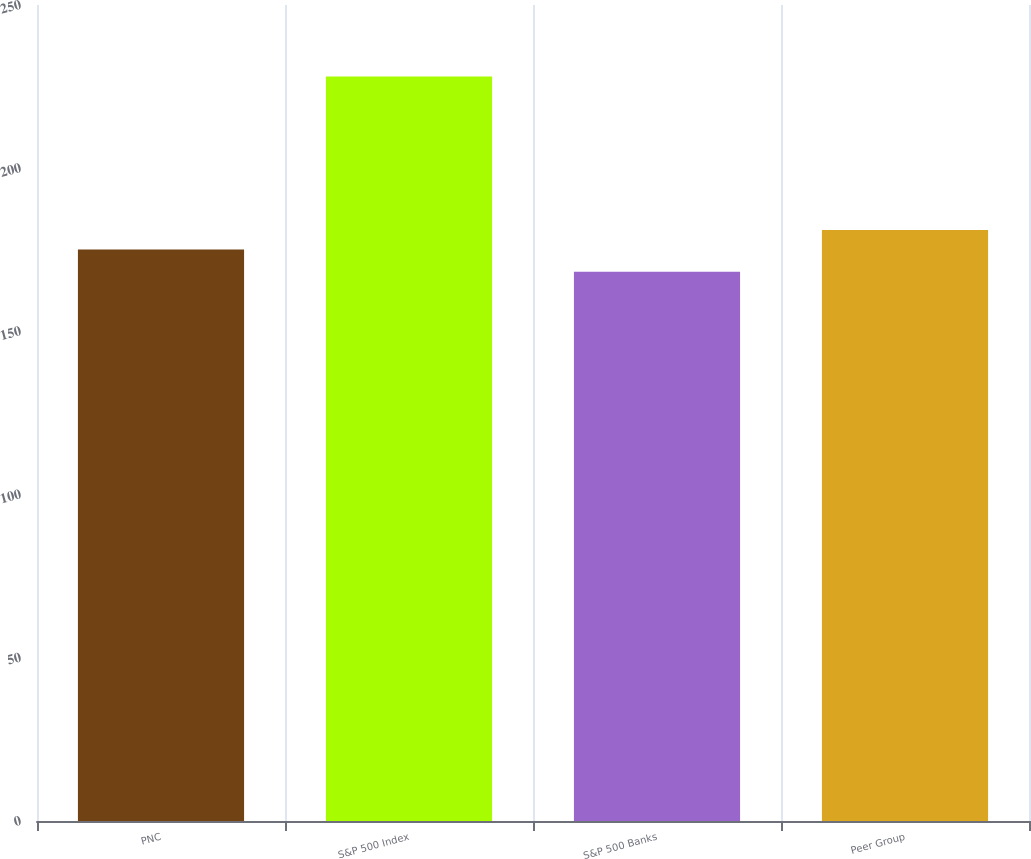Convert chart to OTSL. <chart><loc_0><loc_0><loc_500><loc_500><bar_chart><fcel>PNC<fcel>S&P 500 Index<fcel>S&P 500 Banks<fcel>Peer Group<nl><fcel>175.1<fcel>228.1<fcel>168.29<fcel>181.08<nl></chart> 